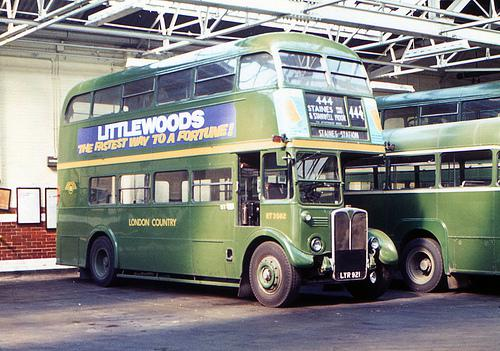Question: what color are the buses?
Choices:
A. Green.
B. Red.
C. White.
D. Blue.
Answer with the letter. Answer: A Question: who drives these buses?
Choices:
A. Men.
B. Women.
C. Employees.
D. Bus drivers.
Answer with the letter. Answer: D Question: what type of buses are these?
Choices:
A. Double-deckers.
B. Local.
C. School.
D. Greyhound.
Answer with the letter. Answer: A Question: how many buses are visible?
Choices:
A. Three.
B. One.
C. Two.
D. Four.
Answer with the letter. Answer: A 